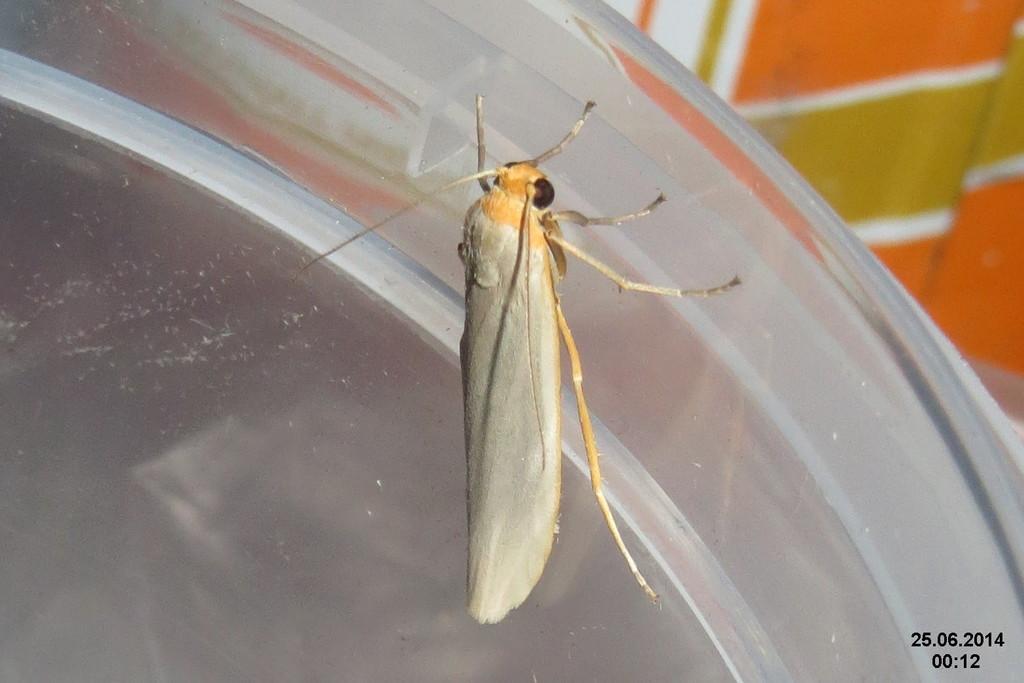Please provide a concise description of this image. In this image we can see a fly on the table. In the background there is a cloth. 